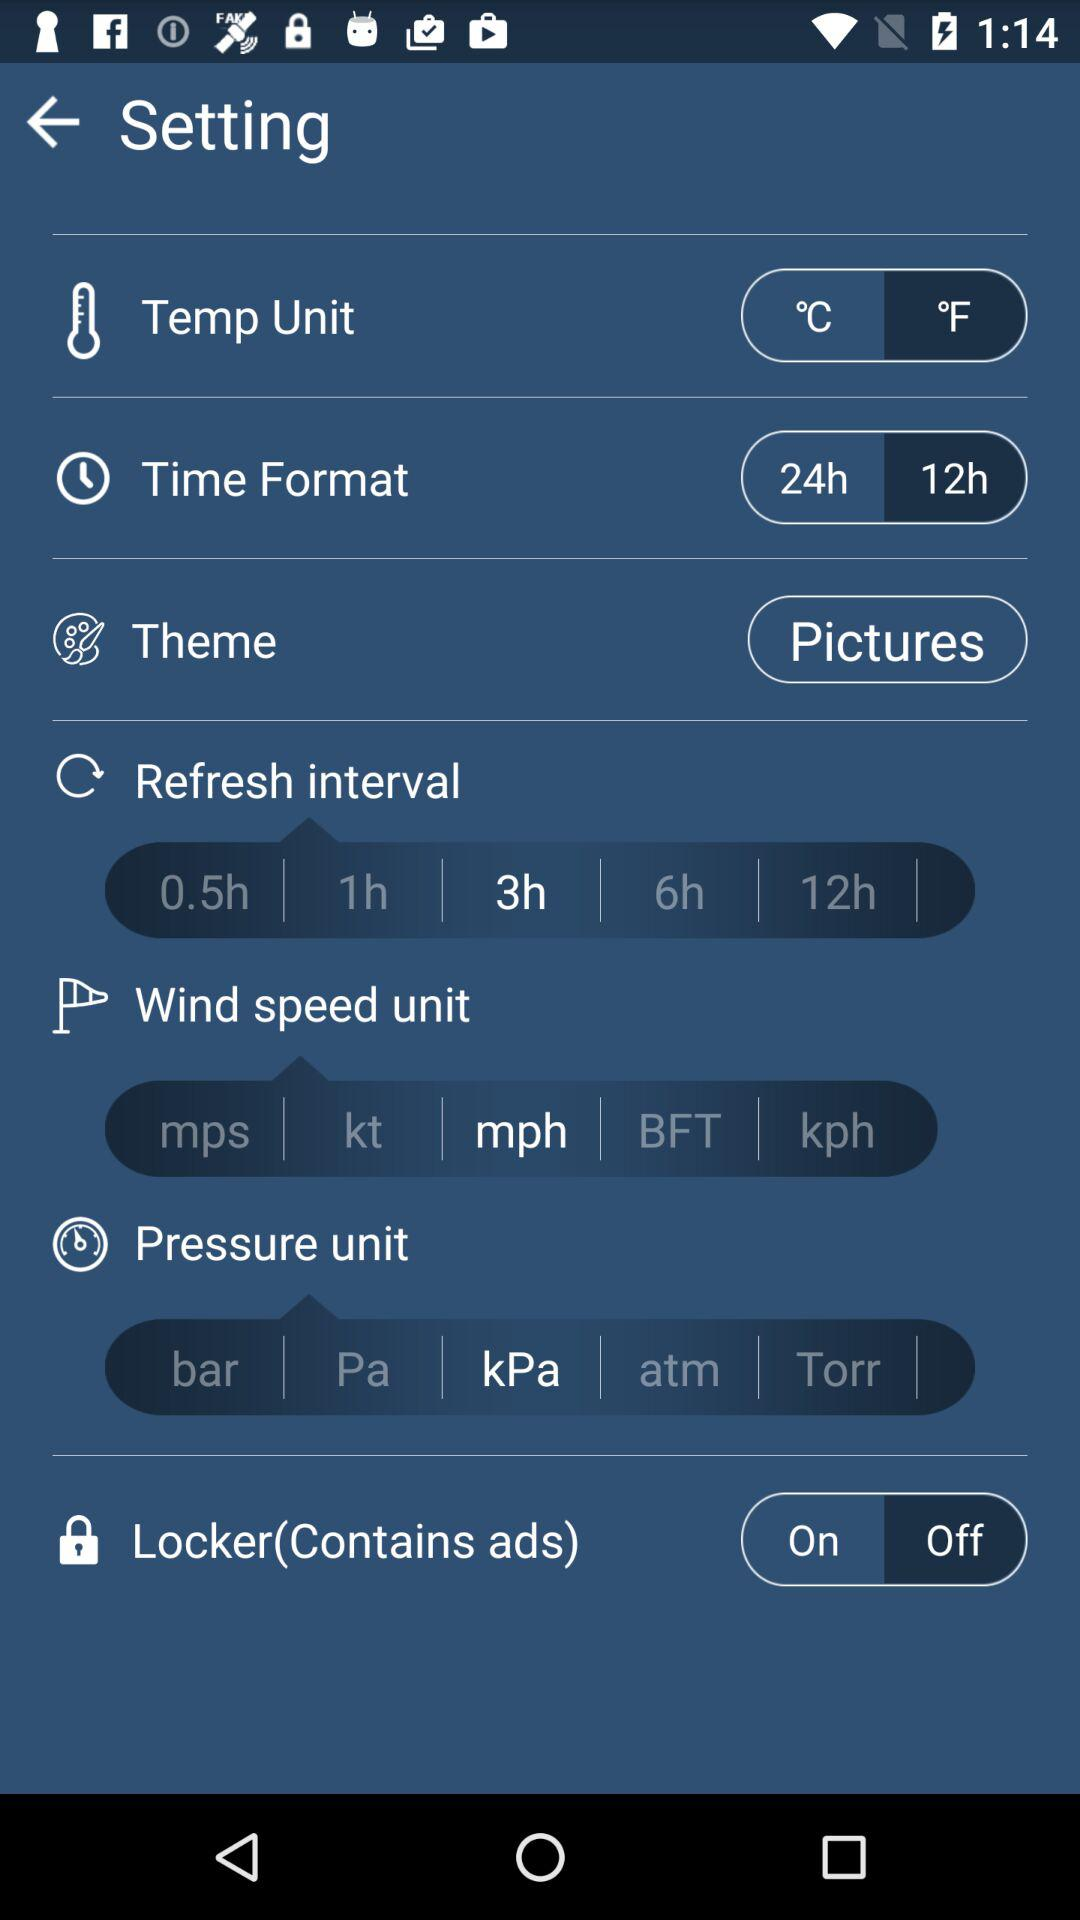What is the current state of the locker setting? The current state of the locker setting is "Off". 